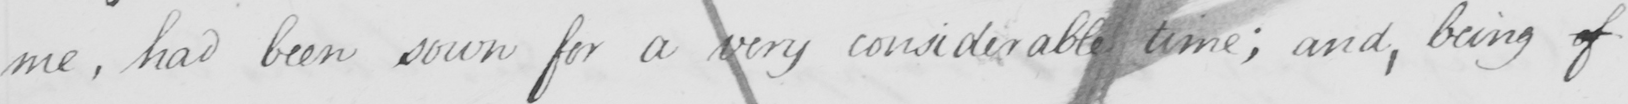What text is written in this handwritten line? me, had been sown for a very considerable time; and, being of 